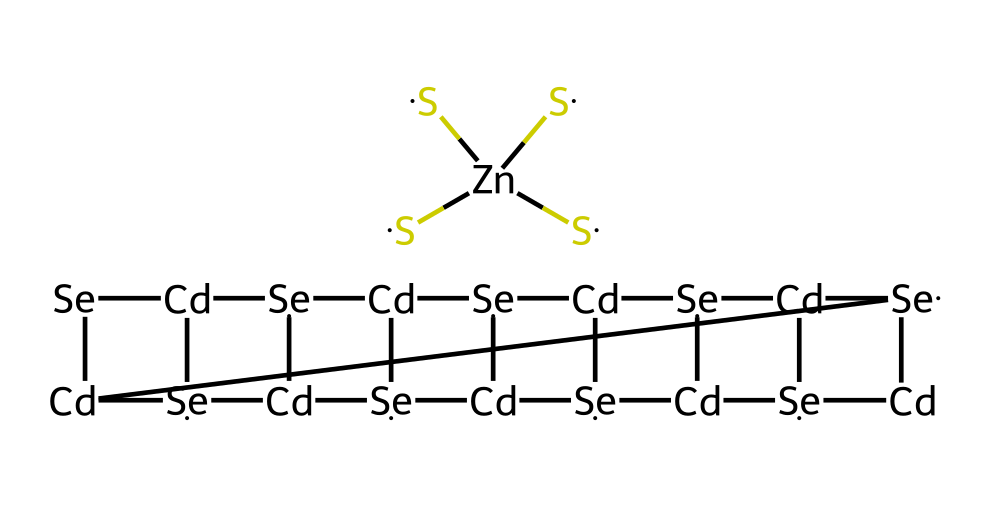What type of quantum dot is represented in this structure? The chemical structure includes cadmium (Cd) and selenium (Se), which are characteristic of cadmium selenide quantum dots, a common type used in bioimaging.
Answer: cadmium selenide How many cadmium atoms are present in the structure? By examining the SMILES representation, one can count the occurrences of "Cd." There are five occurrences of "Cd" in the structure.
Answer: five What role does zinc play in the chemical structure? The presence of zinc in the structure, represented as "Zn," suggests it functions as a dopant or stabilizer to enhance the properties of the quantum dots.
Answer: dopant How many sulfur atoms are attached to zinc in the structure? In the SMILES notation, the "([S])([S])([S])([S])" indicates there are four sulfur atoms bonded to the zinc atom.
Answer: four What is the overall charge of the quantum dot complex? The structure does not indicate any explicit charge through the SMILES notation, suggesting the quantum dot is neutral, as it typically combines an equal number of positive and negative charges.
Answer: neutral What property is enhanced by the presence of cadmium selenide in this quantum dot? Cadmium selenide quantum dots are known for their photoluminescent properties, which are crucial for imaging applications in bioimaging.
Answer: photoluminescence 